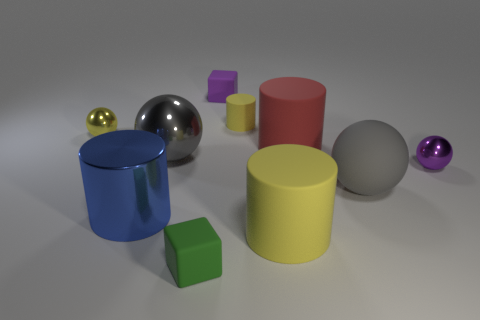How many other objects are the same shape as the big yellow matte object?
Provide a short and direct response. 3. Are there fewer large yellow rubber cylinders than green rubber cylinders?
Make the answer very short. No. Is the size of the purple metallic object the same as the yellow object in front of the big gray shiny thing?
Keep it short and to the point. No. What is the color of the tiny shiny ball that is behind the small metallic thing on the right side of the green matte cube?
Provide a succinct answer. Yellow. How many things are either spheres behind the gray metal ball or cylinders that are behind the big yellow rubber cylinder?
Your answer should be very brief. 4. Does the red matte cylinder have the same size as the blue metal thing?
Your answer should be compact. Yes. Are there any other things that are the same size as the green rubber cube?
Offer a terse response. Yes. Do the tiny metal thing that is left of the matte sphere and the big rubber thing that is in front of the gray rubber thing have the same shape?
Ensure brevity in your answer.  No. What is the size of the purple metallic object?
Make the answer very short. Small. There is a big ball that is left of the tiny rubber cube behind the yellow cylinder in front of the small yellow metal thing; what is it made of?
Offer a very short reply. Metal. 